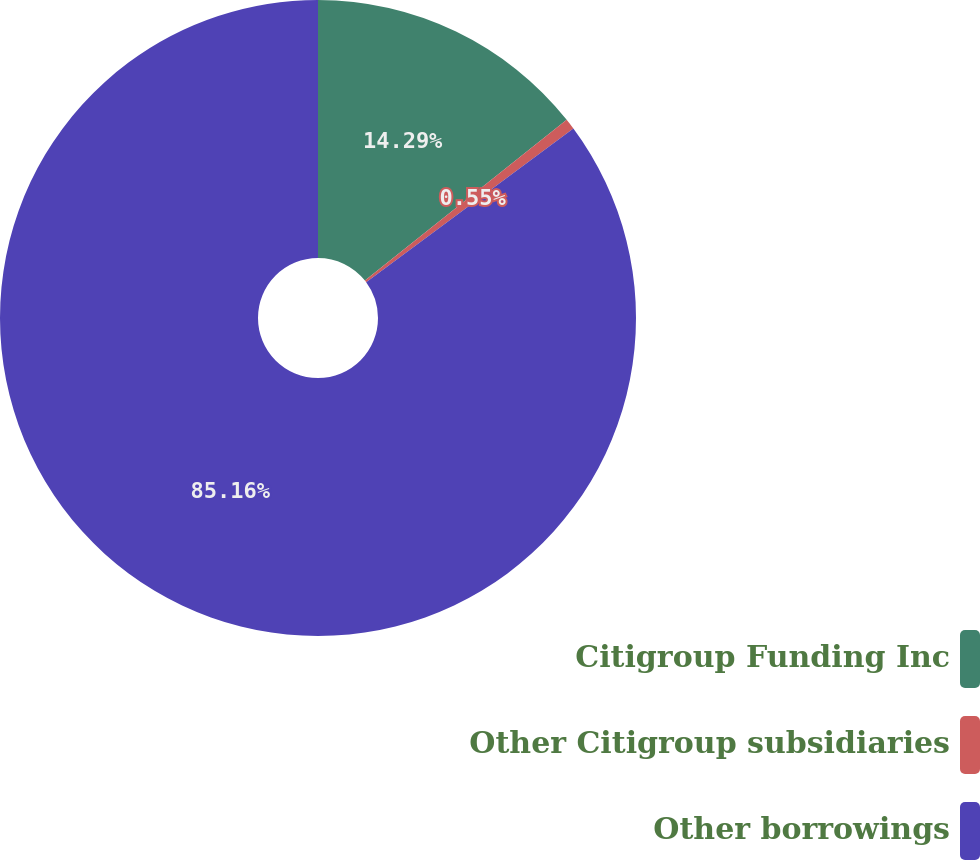Convert chart. <chart><loc_0><loc_0><loc_500><loc_500><pie_chart><fcel>Citigroup Funding Inc<fcel>Other Citigroup subsidiaries<fcel>Other borrowings<nl><fcel>14.29%<fcel>0.55%<fcel>85.16%<nl></chart> 